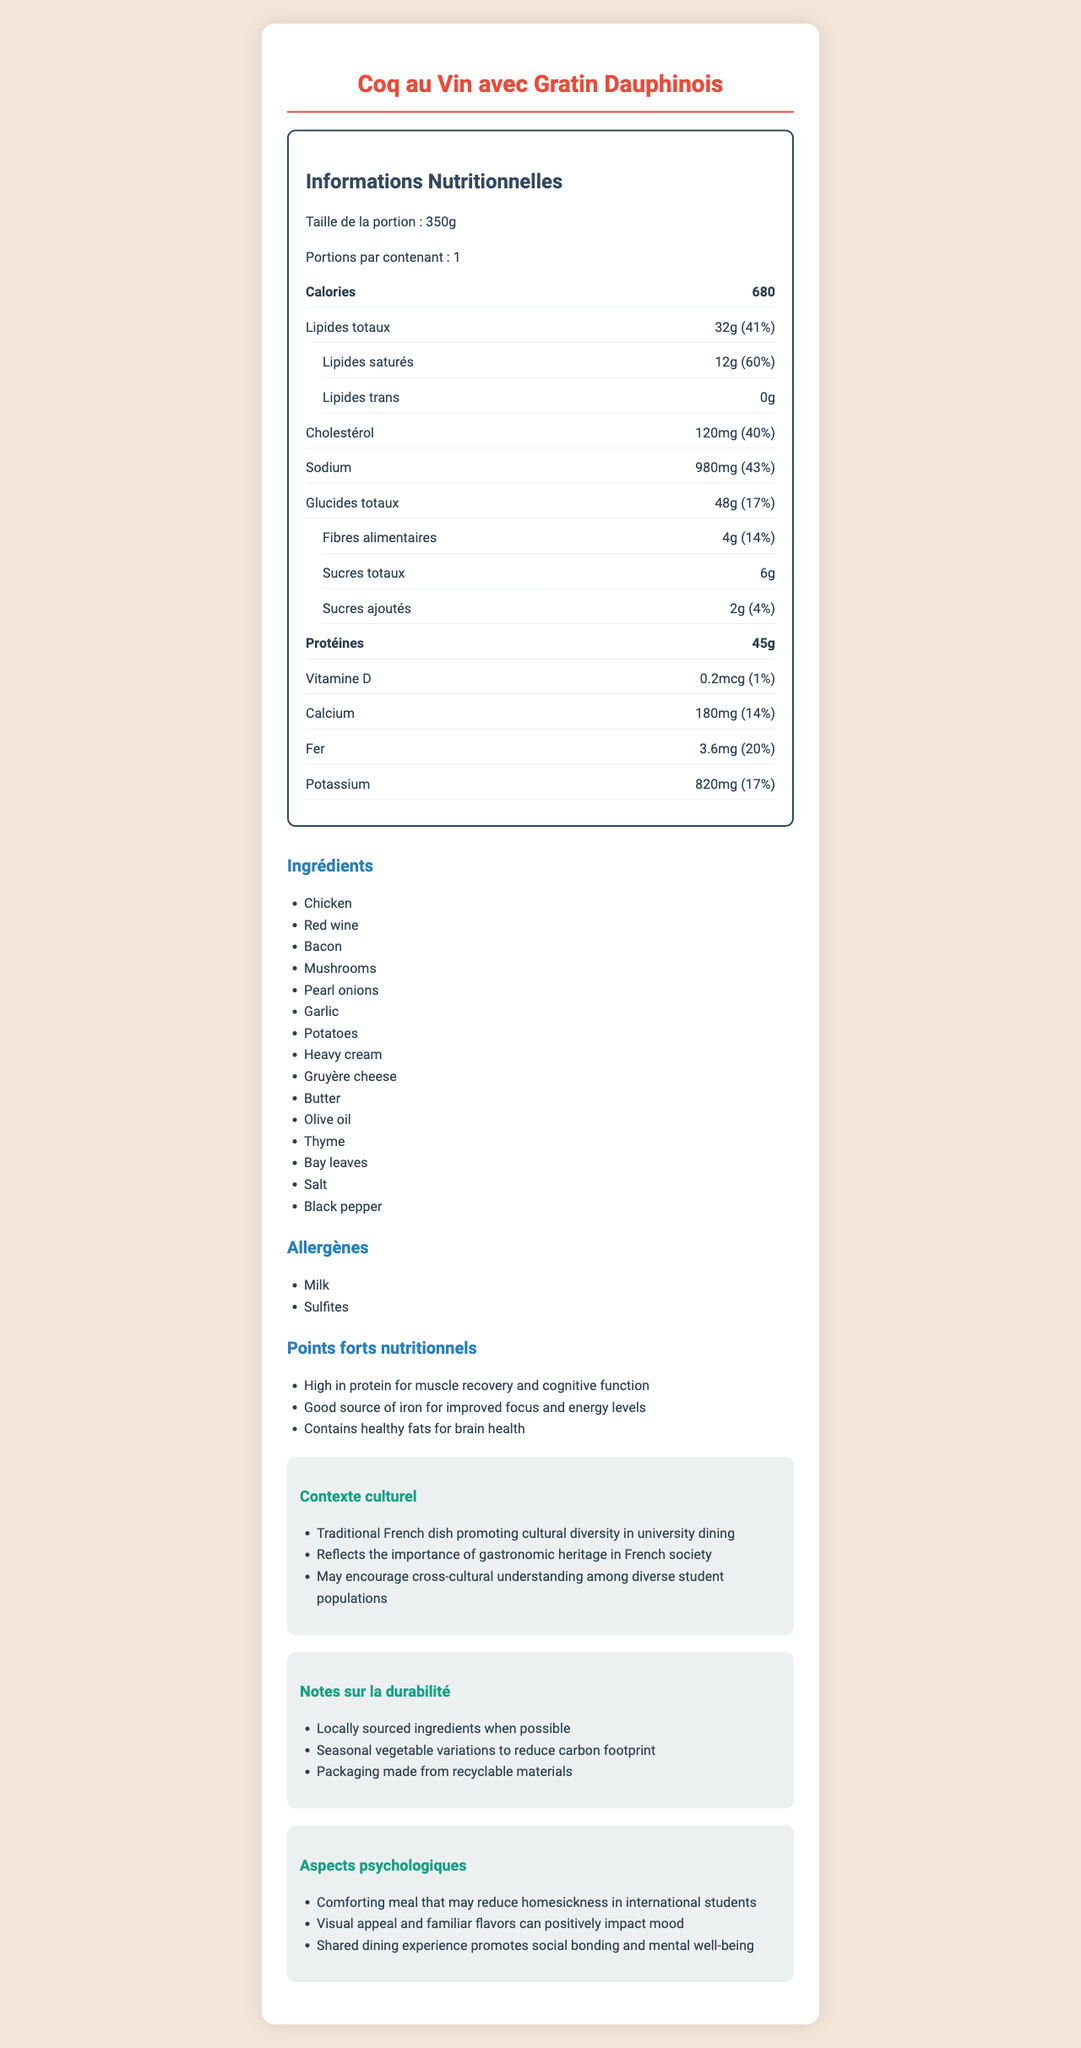what is the serving size for "Coq au Vin avec Gratin Dauphinois"? The serving size is mentioned at the beginning of the nutrition facts section as "Taille de la portion: 350g."
Answer: 350g how many calories does one serving contain? The calories per serving are listed in the bold nutrition item section under calories as "Calories: 680."
Answer: 680 What percentage of the daily value for sodium does this meal provide? The sodium content is listed in the nutrition facts and reads "Sodium 980mg (43%)."
Answer: 43% Which two allergens are present in this meal? The allergens section explicitly lists "Lait" (Milk) and "Sulfites."
Answer: Milk and Sulfites What is the amount of protein per serving? The protein content is listed in the bold nutrition item section under protein as "Protéines: 45g."
Answer: 45g What are some of the psychological benefits of this meal? The psychological benefits are detailed in the psychological aspects section.
Answer: Comforting meal that may reduce homesickness in international students, Visual appeal and familiar flavors can positively impact mood, Shared dining experience promotes social bonding and mental well-being Which ingredient is NOT included in this meal? A. Potatoes B. Butter C. Corn D. Garlic The ingredients listed do not include corn; they list Potatoes, Butter, Garlic, among others.
Answer: C. Corn How much iron does one serving of this meal provide? A. 1.8mg B. 2.5mg C. 3.6mg D. 4.2mg The iron content is listed in the nutrition facts as "Fer 3.6mg (20%)."
Answer: C. 3.6mg Is this meal high in saturated fat? The amount of saturated fat is 12g which is 60% of the daily value, indicating it is high.
Answer: Yes Summarize the main nutritional benefits and cultural context of this meal. The nutritional benefits are highlighted in the nutritional highlights section, and the cultural context is discussed in the corresponding section.
Answer: The meal is high in protein, iron, and contains healthy fats that support muscle recovery, cognitive function, and brain health. From a cultural perspective, it is a traditional French dish that promotes cultural diversity and understanding among university students. What is the source of the vitamin D in this meal? The document does not specify which ingredient provides vitamin D.
Answer: Cannot be determined How does the meal support academic performance? The academic performance benefits are detailed in a dedicated section focusing on how the meal supports cognitive function and memory.
Answer: Balanced macronutrients support cognitive function, Protein-rich meal may improve memory retention, Complex carbohydrates provide steady glucose release for sustained mental performance 